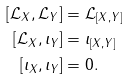Convert formula to latex. <formula><loc_0><loc_0><loc_500><loc_500>[ \mathcal { L } _ { X } , \mathcal { L } _ { Y } ] & = \mathcal { L } _ { [ X , Y ] } \\ [ \mathcal { L } _ { X } , \iota _ { Y } ] & = \iota _ { [ X , Y ] } \\ [ \iota _ { X } , \iota _ { Y } ] & = 0 .</formula> 